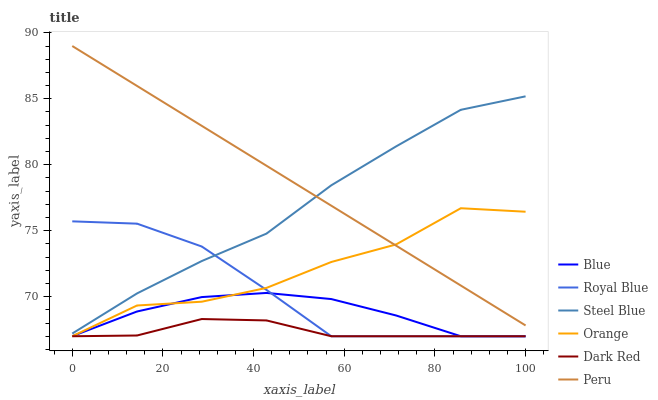Does Dark Red have the minimum area under the curve?
Answer yes or no. Yes. Does Peru have the maximum area under the curve?
Answer yes or no. Yes. Does Steel Blue have the minimum area under the curve?
Answer yes or no. No. Does Steel Blue have the maximum area under the curve?
Answer yes or no. No. Is Peru the smoothest?
Answer yes or no. Yes. Is Orange the roughest?
Answer yes or no. Yes. Is Dark Red the smoothest?
Answer yes or no. No. Is Dark Red the roughest?
Answer yes or no. No. Does Blue have the lowest value?
Answer yes or no. Yes. Does Steel Blue have the lowest value?
Answer yes or no. No. Does Peru have the highest value?
Answer yes or no. Yes. Does Steel Blue have the highest value?
Answer yes or no. No. Is Blue less than Peru?
Answer yes or no. Yes. Is Peru greater than Blue?
Answer yes or no. Yes. Does Dark Red intersect Orange?
Answer yes or no. Yes. Is Dark Red less than Orange?
Answer yes or no. No. Is Dark Red greater than Orange?
Answer yes or no. No. Does Blue intersect Peru?
Answer yes or no. No. 